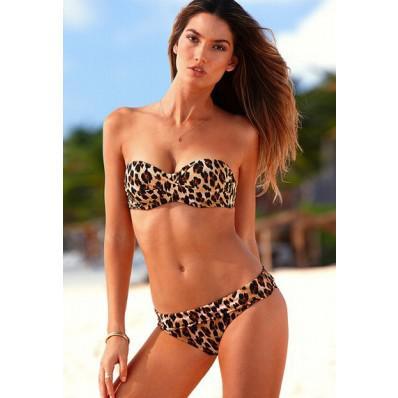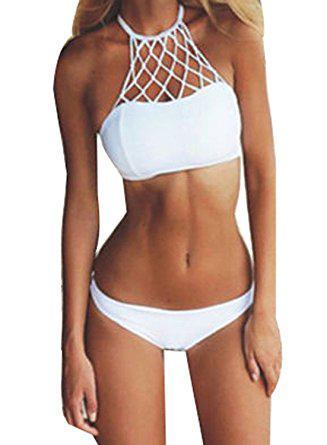The first image is the image on the left, the second image is the image on the right. Given the left and right images, does the statement "You can see a swimming pool behind at least one of the models." hold true? Answer yes or no. No. 